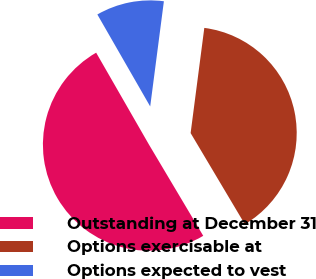Convert chart to OTSL. <chart><loc_0><loc_0><loc_500><loc_500><pie_chart><fcel>Outstanding at December 31<fcel>Options exercisable at<fcel>Options expected to vest<nl><fcel>50.24%<fcel>39.4%<fcel>10.36%<nl></chart> 